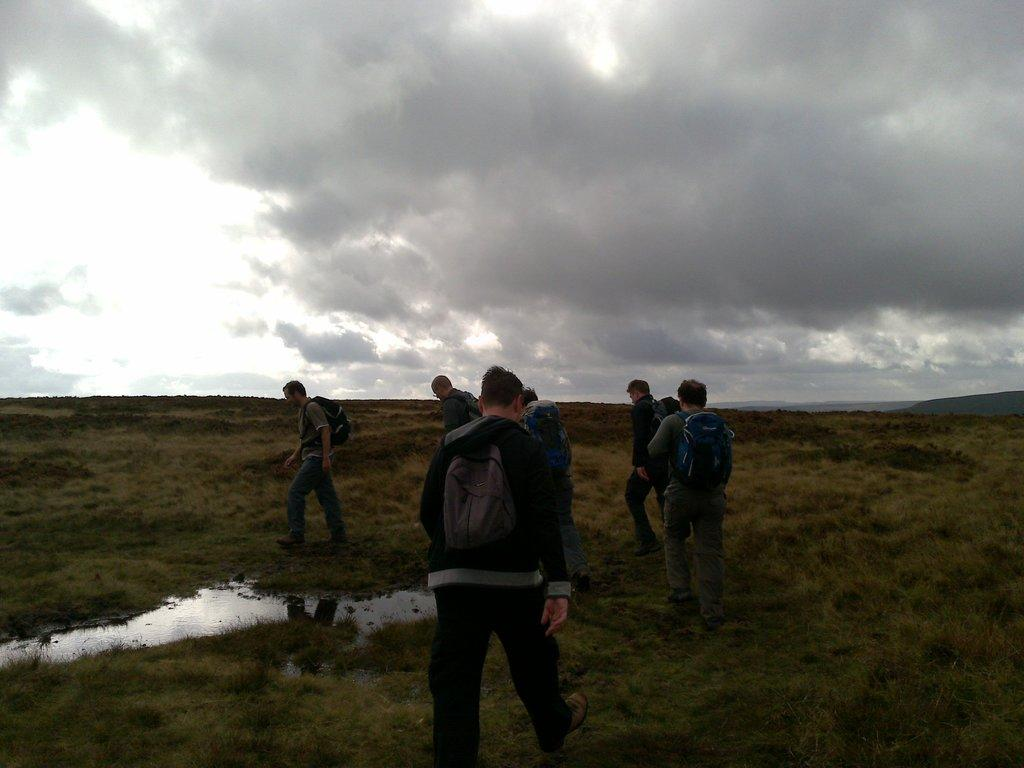Who or what can be seen in the image? There are people in the image. What are the people wearing? The people are wearing bags. What are the people doing in the image? The people are walking on the ground. What else can be seen in the image besides the people? There is water visible in the image. What is the condition of the sky in the image? There are clouds in the sky. How many hydrants can be seen in the image? There are no hydrants visible in the image. Can you describe the person walking next to the hydrant in the image? There is no person walking next to a hydrant in the image, as there are no hydrants present. 